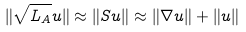Convert formula to latex. <formula><loc_0><loc_0><loc_500><loc_500>\| \sqrt { L _ { A } } u \| \approx \| S u \| \approx \| \nabla u \| + \| u \|</formula> 